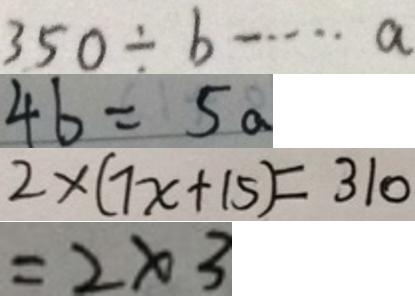<formula> <loc_0><loc_0><loc_500><loc_500>3 5 0 \div b \cdots a 
 4 b = 5 a 
 2 \times ( 7 x + 1 5 ) = 3 1 0 
 = 2 \times 3</formula> 